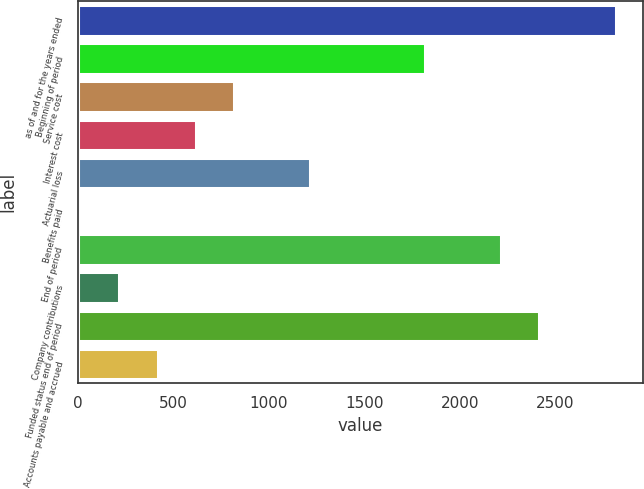Convert chart to OTSL. <chart><loc_0><loc_0><loc_500><loc_500><bar_chart><fcel>as of and for the years ended<fcel>Beginning of period<fcel>Service cost<fcel>Interest cost<fcel>Actuarial loss<fcel>Benefits paid<fcel>End of period<fcel>Company contributions<fcel>Funded status end of period<fcel>Accounts payable and accrued<nl><fcel>2817.8<fcel>1816.8<fcel>815.8<fcel>615.6<fcel>1216.2<fcel>15<fcel>2217.2<fcel>215.2<fcel>2417.4<fcel>415.4<nl></chart> 